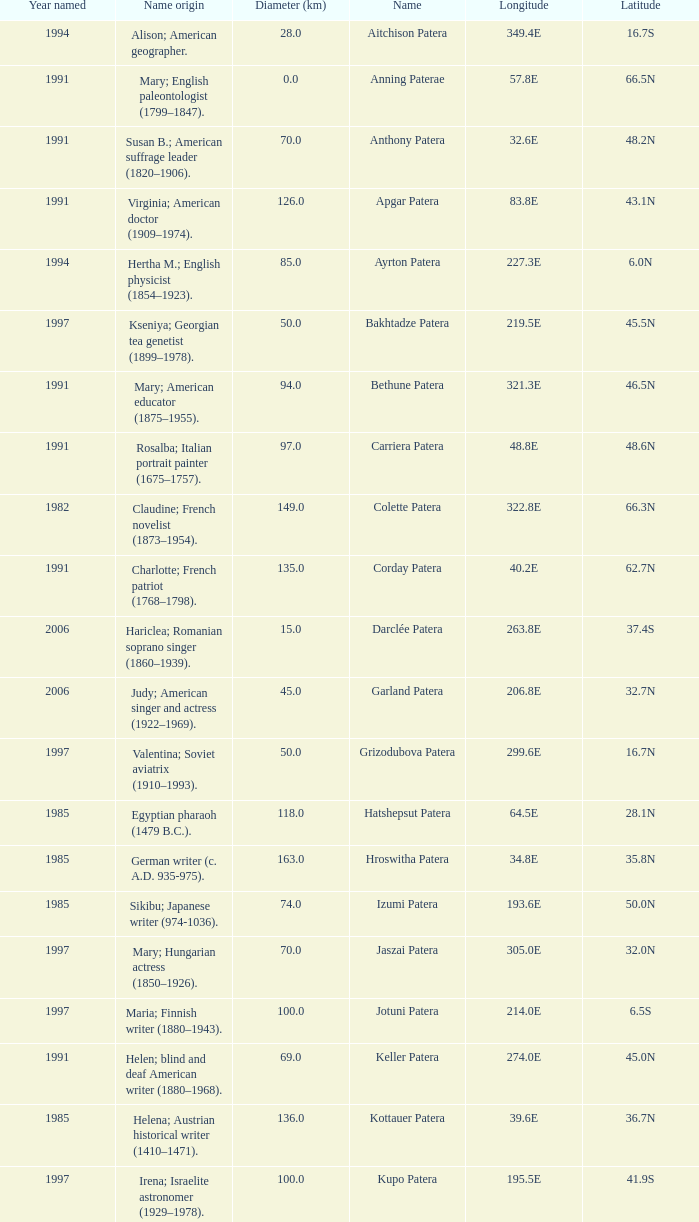What is the diameter in km of the feature named Colette Patera?  149.0. 